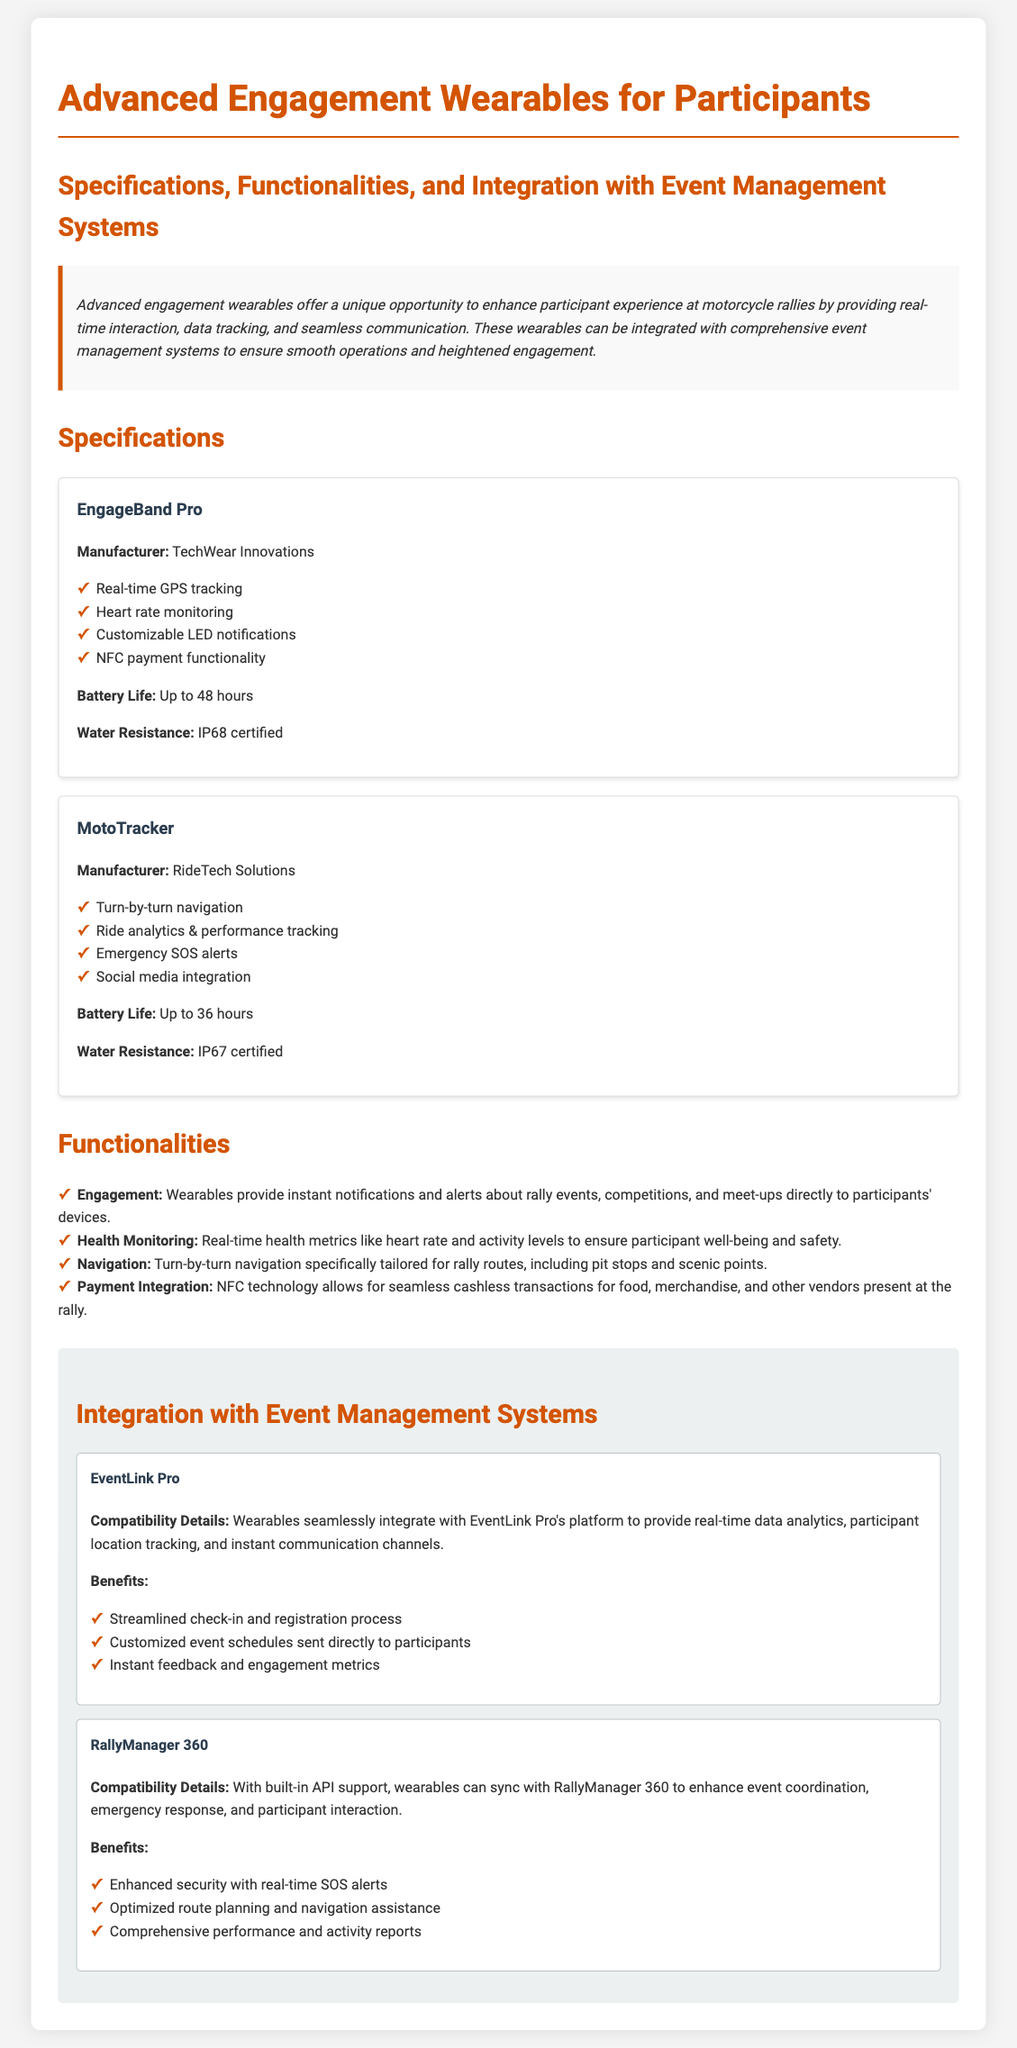What is the battery life of EngageBand Pro? The battery life for EngageBand Pro is specified in the document.
Answer: Up to 48 hours Who is the manufacturer of MotoTracker? The document provides the manufacturer's name for each wearable.
Answer: RideTech Solutions What certification does EngageBand Pro have for water resistance? The document mentions the water resistance certification for EngageBand Pro.
Answer: IP68 certified Which system offers real-time SOS alerts as a benefit? The document lists benefits of integrating with different event management systems.
Answer: RallyManager 360 What is a key functionality of the wearables? The functionalities section lists features offered by the wearables to enhance participant experience.
Answer: Health Monitoring How many integration options are mentioned in the document? The document specifies the number of integration systems available for the wearables.
Answer: Two What feature allows for cashless transactions? The document identifies which technology enables cashless transactions at the event.
Answer: NFC payment functionality What kind of notifications do wearables provide to participants? This information is detailed under the functionalities section.
Answer: Instant notifications What is the purpose of turn-by-turn navigation? The functionalities section explains how navigation is tailored for the rally.
Answer: Rally routes 